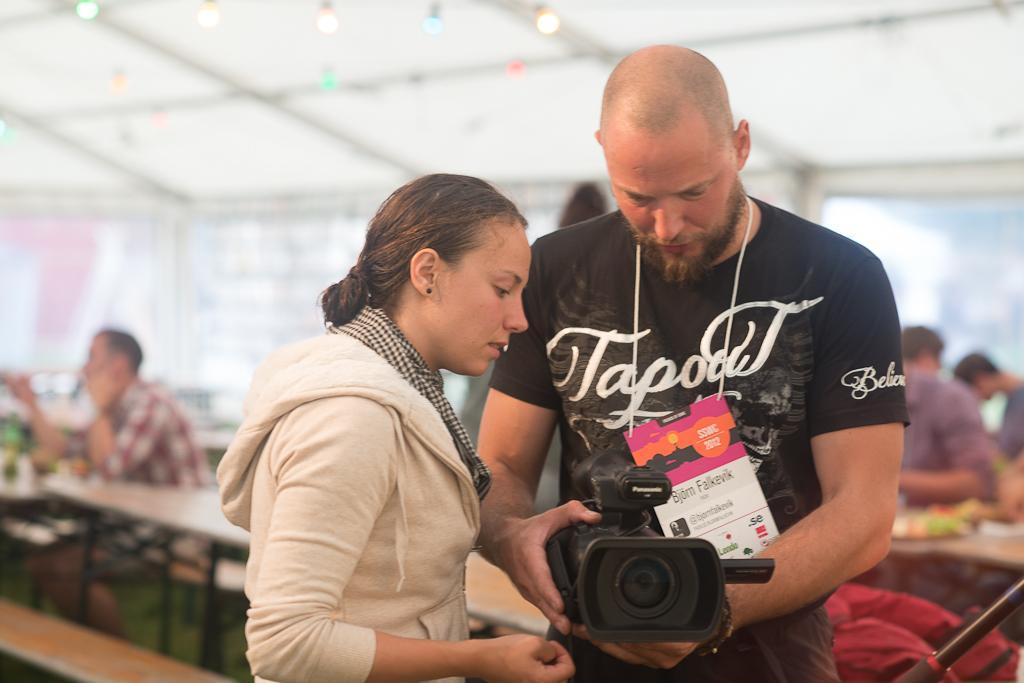Describe this image in one or two sentences. In this image, we can see few peoples. In the center of the image, the man is holding a camera. Beside him, we can see a woman is standing. On the left side of the image, we can see man is sat on the table. On the right side of the image, we can see few peoples. We can see lights on the roof 